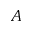Convert formula to latex. <formula><loc_0><loc_0><loc_500><loc_500>A</formula> 